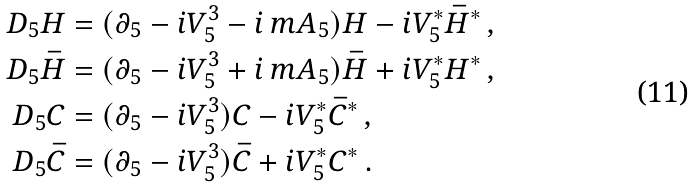<formula> <loc_0><loc_0><loc_500><loc_500>D _ { 5 } H & = ( \partial _ { 5 } - i V ^ { 3 } _ { 5 } - i \, m A _ { 5 } ) H - i V ^ { * } _ { 5 } \bar { H } ^ { * } \, , \\ D _ { 5 } \bar { H } & = ( \partial _ { 5 } - i V ^ { 3 } _ { 5 } + i \, m A _ { 5 } ) \bar { H } + i V ^ { * } _ { 5 } H ^ { * } \, , \\ D _ { 5 } C & = ( \partial _ { 5 } - i V ^ { 3 } _ { 5 } ) C - i V ^ { * } _ { 5 } \bar { C } ^ { * } \, , \\ D _ { 5 } \bar { C } & = ( \partial _ { 5 } - i V ^ { 3 } _ { 5 } ) \bar { C } + i V ^ { * } _ { 5 } C ^ { * } \, .</formula> 